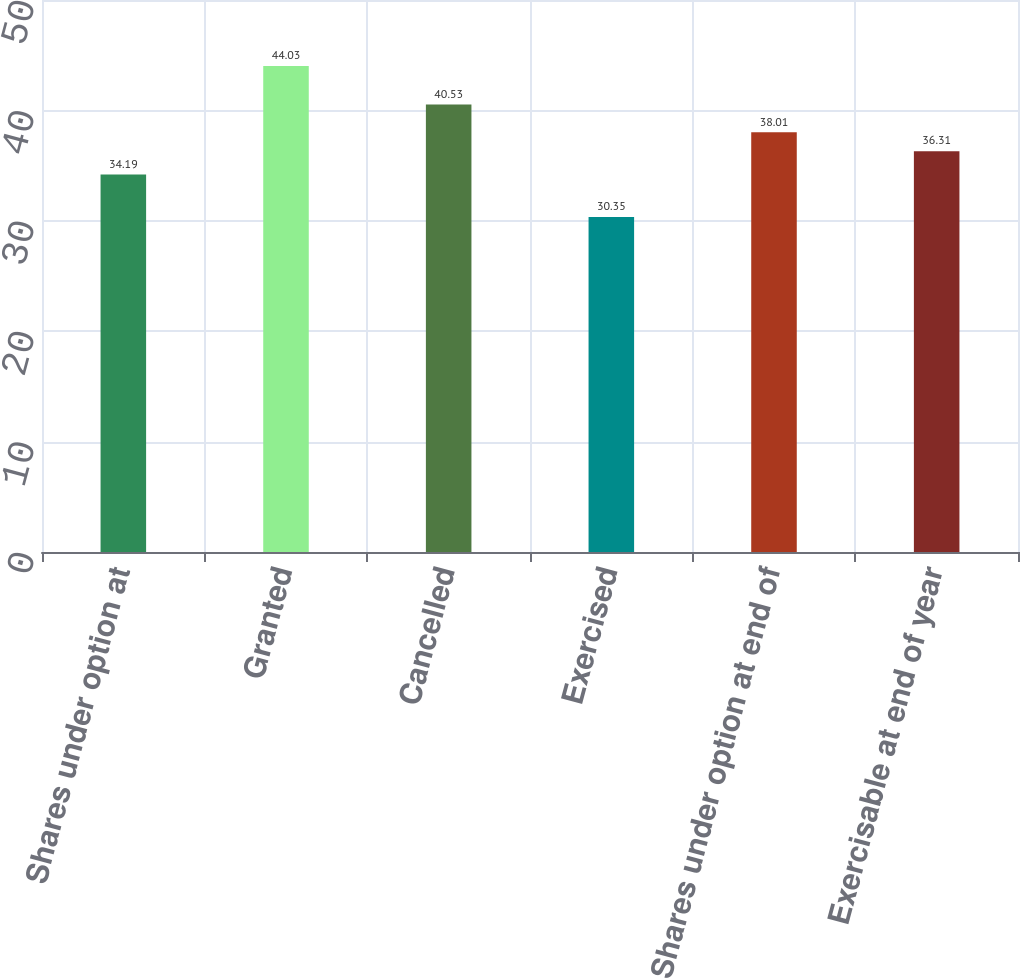<chart> <loc_0><loc_0><loc_500><loc_500><bar_chart><fcel>Shares under option at<fcel>Granted<fcel>Cancelled<fcel>Exercised<fcel>Shares under option at end of<fcel>Exercisable at end of year<nl><fcel>34.19<fcel>44.03<fcel>40.53<fcel>30.35<fcel>38.01<fcel>36.31<nl></chart> 